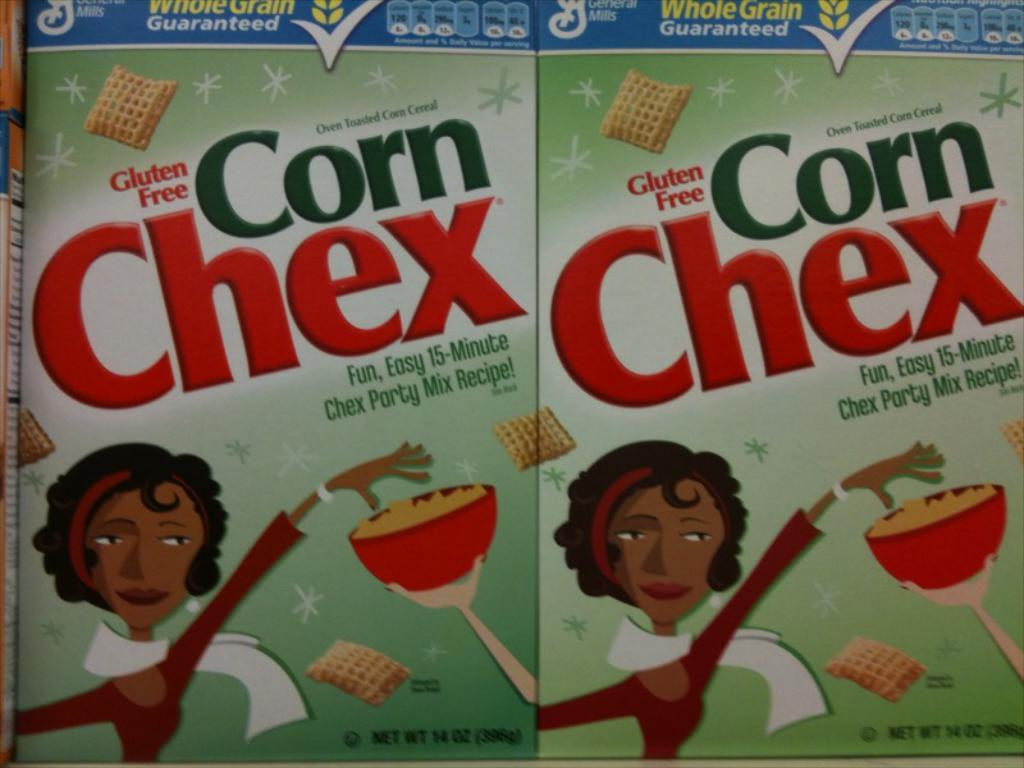How many snack boxes are visible in the image? There are two snack boxes in the image. What is written on the snack boxes? The snack boxes have the name "corn checks." Who is the creator of the wall that can be seen in the image? There is no wall present in the image, so it is not possible to determine who the creator might be. 